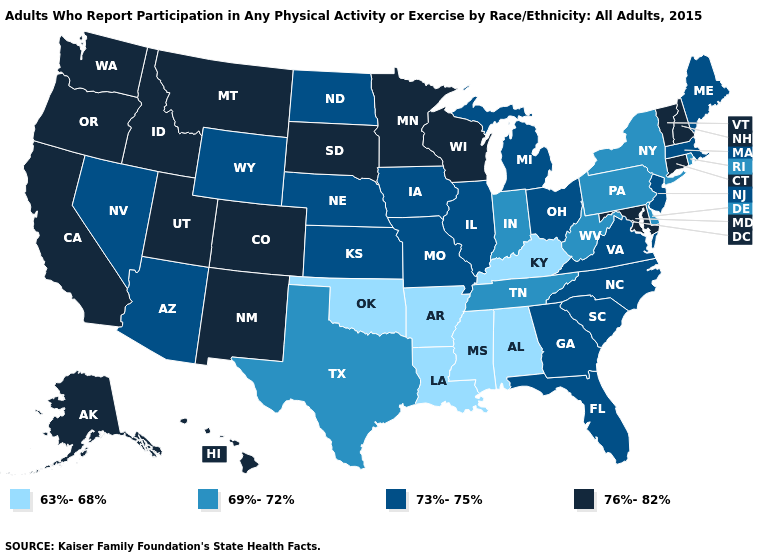Name the states that have a value in the range 69%-72%?
Quick response, please. Delaware, Indiana, New York, Pennsylvania, Rhode Island, Tennessee, Texas, West Virginia. What is the value of Florida?
Concise answer only. 73%-75%. Does Alaska have a lower value than Delaware?
Keep it brief. No. Among the states that border Arizona , which have the highest value?
Quick response, please. California, Colorado, New Mexico, Utah. How many symbols are there in the legend?
Concise answer only. 4. How many symbols are there in the legend?
Give a very brief answer. 4. Name the states that have a value in the range 73%-75%?
Write a very short answer. Arizona, Florida, Georgia, Illinois, Iowa, Kansas, Maine, Massachusetts, Michigan, Missouri, Nebraska, Nevada, New Jersey, North Carolina, North Dakota, Ohio, South Carolina, Virginia, Wyoming. Does Ohio have the same value as South Carolina?
Give a very brief answer. Yes. Among the states that border Nebraska , does Iowa have the lowest value?
Concise answer only. Yes. What is the highest value in states that border Iowa?
Write a very short answer. 76%-82%. Name the states that have a value in the range 69%-72%?
Be succinct. Delaware, Indiana, New York, Pennsylvania, Rhode Island, Tennessee, Texas, West Virginia. What is the highest value in the USA?
Concise answer only. 76%-82%. What is the value of Oregon?
Quick response, please. 76%-82%. What is the highest value in states that border Indiana?
Write a very short answer. 73%-75%. What is the lowest value in the USA?
Give a very brief answer. 63%-68%. 